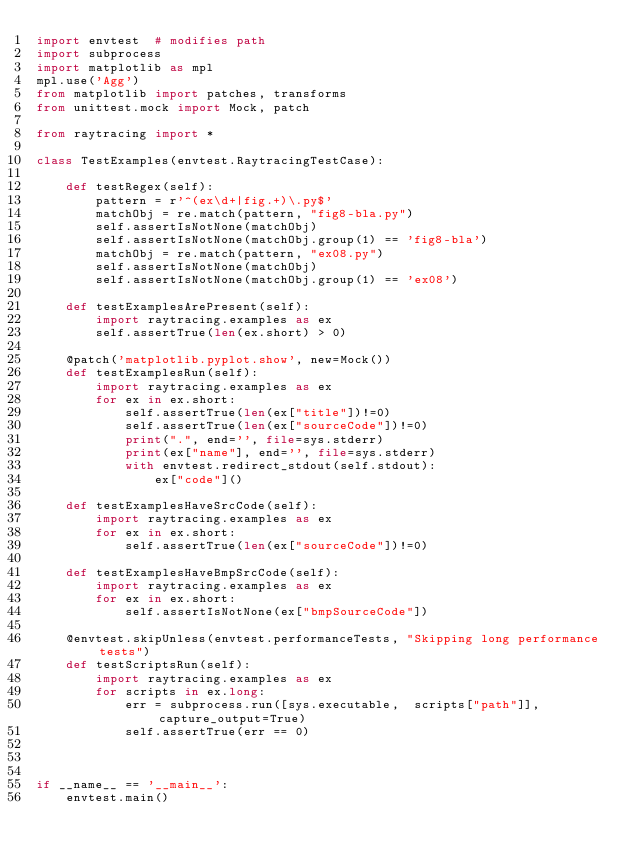<code> <loc_0><loc_0><loc_500><loc_500><_Python_>import envtest  # modifies path
import subprocess
import matplotlib as mpl
mpl.use('Agg')
from matplotlib import patches, transforms
from unittest.mock import Mock, patch

from raytracing import *

class TestExamples(envtest.RaytracingTestCase):

    def testRegex(self):
        pattern = r'^(ex\d+|fig.+)\.py$'
        matchObj = re.match(pattern, "fig8-bla.py")
        self.assertIsNotNone(matchObj)
        self.assertIsNotNone(matchObj.group(1) == 'fig8-bla')
        matchObj = re.match(pattern, "ex08.py")
        self.assertIsNotNone(matchObj)
        self.assertIsNotNone(matchObj.group(1) == 'ex08')

    def testExamplesArePresent(self):
        import raytracing.examples as ex
        self.assertTrue(len(ex.short) > 0)

    @patch('matplotlib.pyplot.show', new=Mock())
    def testExamplesRun(self):
        import raytracing.examples as ex
        for ex in ex.short:
            self.assertTrue(len(ex["title"])!=0)
            self.assertTrue(len(ex["sourceCode"])!=0)
            print(".", end='', file=sys.stderr)
            print(ex["name"], end='', file=sys.stderr)
            with envtest.redirect_stdout(self.stdout):
                ex["code"]()

    def testExamplesHaveSrcCode(self):
        import raytracing.examples as ex
        for ex in ex.short:
            self.assertTrue(len(ex["sourceCode"])!=0)

    def testExamplesHaveBmpSrcCode(self):
        import raytracing.examples as ex
        for ex in ex.short:
            self.assertIsNotNone(ex["bmpSourceCode"])

    @envtest.skipUnless(envtest.performanceTests, "Skipping long performance tests")
    def testScriptsRun(self):
        import raytracing.examples as ex
        for scripts in ex.long:
            err = subprocess.run([sys.executable,  scripts["path"]], capture_output=True)
            self.assertTrue(err == 0)
    


if __name__ == '__main__':
    envtest.main()
</code> 